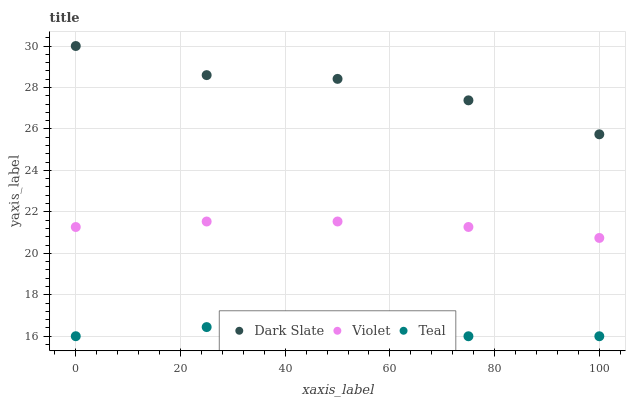Does Teal have the minimum area under the curve?
Answer yes or no. Yes. Does Dark Slate have the maximum area under the curve?
Answer yes or no. Yes. Does Violet have the minimum area under the curve?
Answer yes or no. No. Does Violet have the maximum area under the curve?
Answer yes or no. No. Is Violet the smoothest?
Answer yes or no. Yes. Is Dark Slate the roughest?
Answer yes or no. Yes. Is Teal the smoothest?
Answer yes or no. No. Is Teal the roughest?
Answer yes or no. No. Does Teal have the lowest value?
Answer yes or no. Yes. Does Violet have the lowest value?
Answer yes or no. No. Does Dark Slate have the highest value?
Answer yes or no. Yes. Does Violet have the highest value?
Answer yes or no. No. Is Teal less than Dark Slate?
Answer yes or no. Yes. Is Dark Slate greater than Teal?
Answer yes or no. Yes. Does Teal intersect Dark Slate?
Answer yes or no. No. 